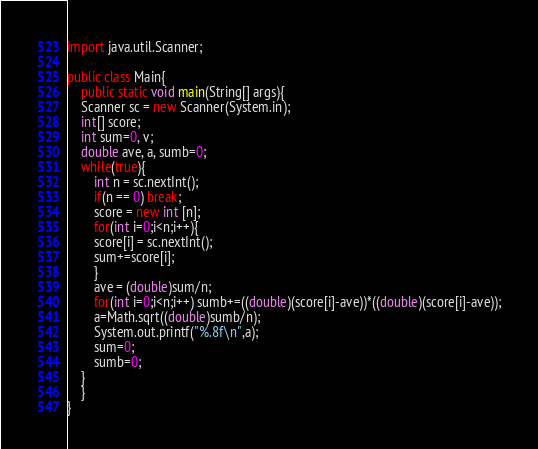Convert code to text. <code><loc_0><loc_0><loc_500><loc_500><_Java_>import java.util.Scanner;

public class Main{
    public static void main(String[] args){
	Scanner sc = new Scanner(System.in);
	int[] score;
	int sum=0, v;
	double ave, a, sumb=0;
	while(true){
	    int n = sc.nextInt();
	    if(n == 0) break;
	    score = new int [n];
	    for(int i=0;i<n;i++){
		score[i] = sc.nextInt();
		sum+=score[i]; 
	    }
	    ave = (double)sum/n;
	    for(int i=0;i<n;i++) sumb+=((double)(score[i]-ave))*((double)(score[i]-ave));
	    a=Math.sqrt((double)sumb/n);
	    System.out.printf("%.8f\n",a);	
	    sum=0;
	    sumb=0;
	}
    }
}</code> 